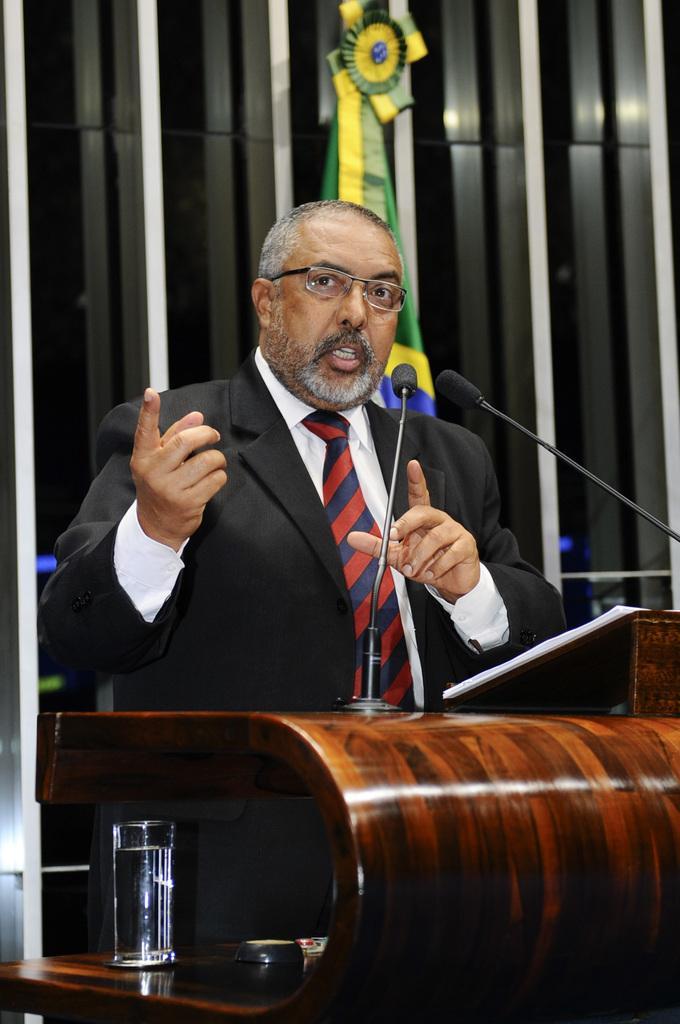Please provide a concise description of this image. In this image we can see a man is standing near the podium, he is wearing the black suit, in front there is a microphone, there is a glass, at the back there is a flag. 